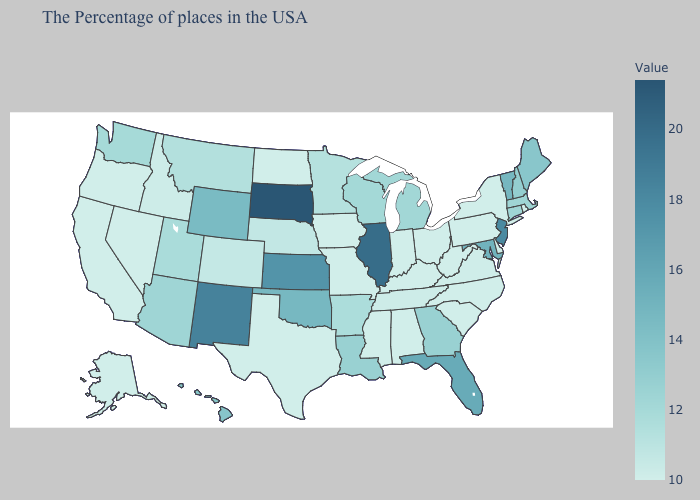Does Minnesota have the highest value in the MidWest?
Quick response, please. No. Does Arizona have the highest value in the USA?
Keep it brief. No. Which states have the lowest value in the South?
Concise answer only. Delaware, North Carolina, South Carolina, West Virginia, Kentucky, Alabama, Mississippi, Texas. Does Indiana have the lowest value in the MidWest?
Answer briefly. Yes. Which states have the lowest value in the Northeast?
Write a very short answer. Rhode Island, New York, Pennsylvania. Does Michigan have a lower value than Idaho?
Give a very brief answer. No. Among the states that border Tennessee , which have the highest value?
Short answer required. Georgia. 